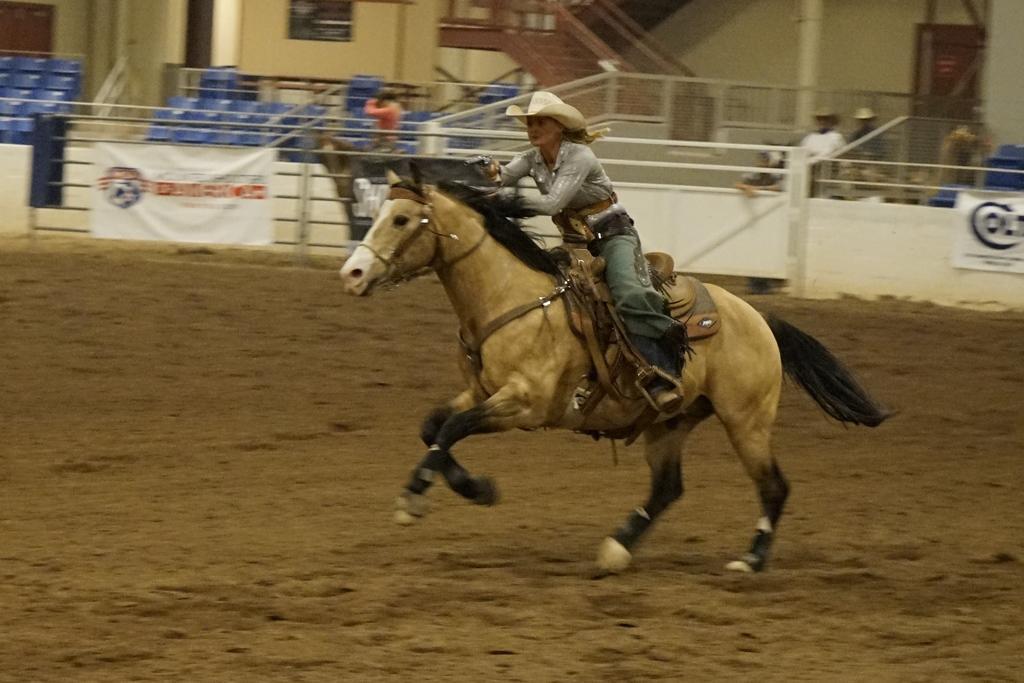How would you summarize this image in a sentence or two? In this image we can see a person wearing hat is riding a horse. In the back there is a wall. Also there is railing. And there are banners. And we can see few people. And there is a building. And there are steps with railings. 